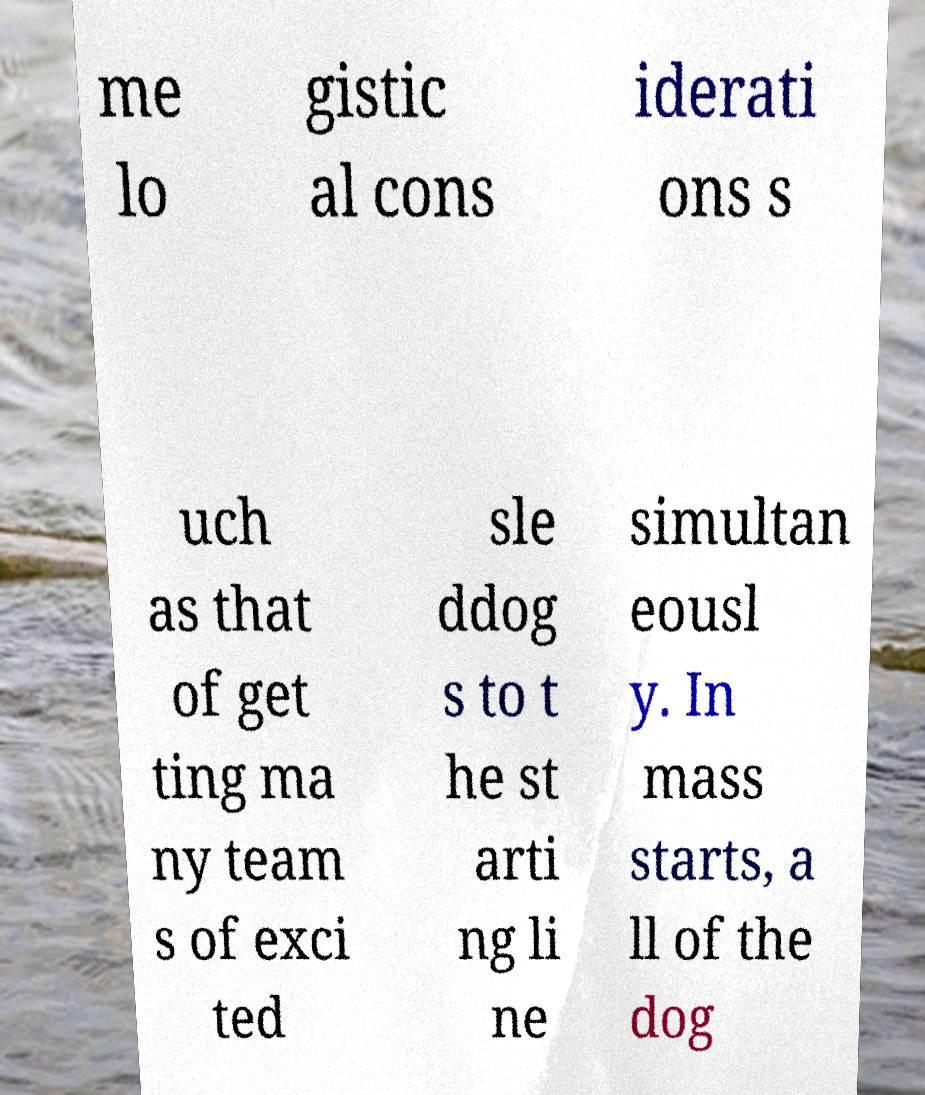I need the written content from this picture converted into text. Can you do that? me lo gistic al cons iderati ons s uch as that of get ting ma ny team s of exci ted sle ddog s to t he st arti ng li ne simultan eousl y. In mass starts, a ll of the dog 